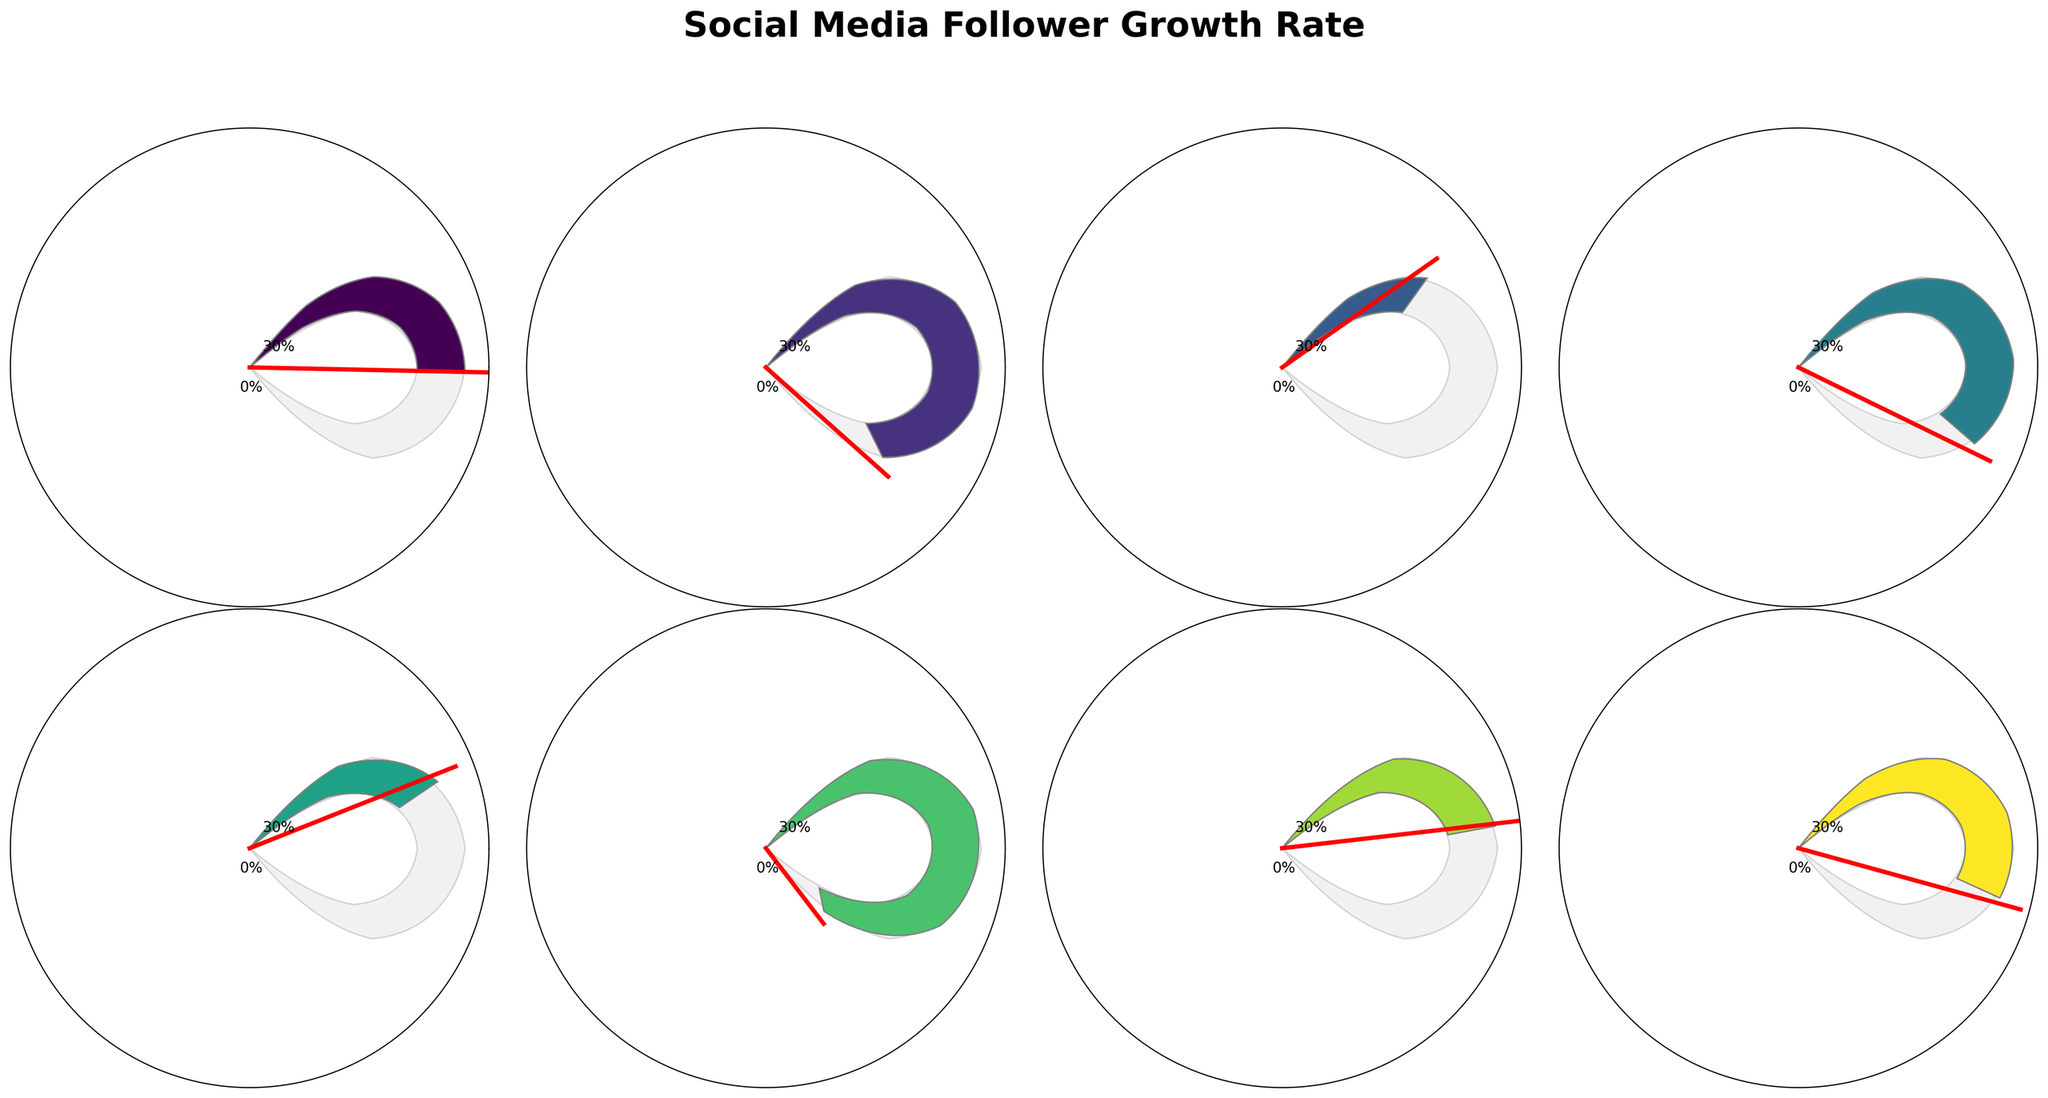What's the title of the figure? The title is displayed prominently on the plot, centered at the top, above all the gauge charts. It is usually in a larger and bold font for clear visibility.
Answer: Social Media Follower Growth Rate How many contestants are shown in the figure? Each contestant is represented by a separate gauge chart. By counting all the individual gauges, we can determine the number of contestants. There are 2 rows and 4 columns of gauge charts.
Answer: 8 Which contestant has the highest follower growth rate? By observing the needle positions and the percentage labels on each gauge chart, we can identify the gauge with the highest percentage value.
Answer: Aiden Patel What is the follower growth rate for Sophia Lee? Locate Sophia Lee's gauge chart and read the percentage value displayed near the bottom of the gauge. The needle position also indicates this value.
Answer: 8.7% What is the average follower growth rate of all contestants? Sum all the follower growth rates and then divide by the number of contestants. The rates are: 15.2 + 22.8 + 8.7 + 19.5 + 11.3 + 26.1 + 13.9 + 17.6. The average is (15.2 + 22.8 + 8.7 + 19.5 + 11.3 + 26.1 + 13.9 + 17.6) / 8 = 17.37
Answer: 17.37 Who has a growth rate closest to the average? Calculate the average follower growth rate and compare each contestant's rate to this average, then determine which is the closest. The average rate is 17.37%. Comparing each rate to this, Liam O'Connor's 17.6% is the closest.
Answer: Liam O'Connor Which contestants have growth rates above the average? Calculate the average follower growth rate and identify which contestants' rates are higher than this value. The average rate is 17.37%. Contestants above this rate are: Carlos Rodriguez, Jackson Wright, Aiden Patel, and Liam O'Connor.
Answer: Carlos Rodriguez, Jackson Wright, Aiden Patel, Liam O'Connor What is the difference in follower growth rate between the highest and the lowest scoring contestants? Identify the highest and lowest growth rates from the gauge charts, then subtract the lowest rate from the highest rate. Highest rate is 26.1% (Aiden Patel), and the lowest rate is 8.7% (Sophia Lee). The difference is 26.1% - 8.7% = 17.4%
Answer: 17.4% What percentage of the maximum rate has Olivia Chen achieved? Calculate the ratio of Olivia Chen’s rate to the maximum rate and express it as a percentage. Olivia Chen's rate is 11.3%, and the maximum rate is 30%. Thus, (11.3 / 30) * 100 = 37.67%.
Answer: 37.67% 